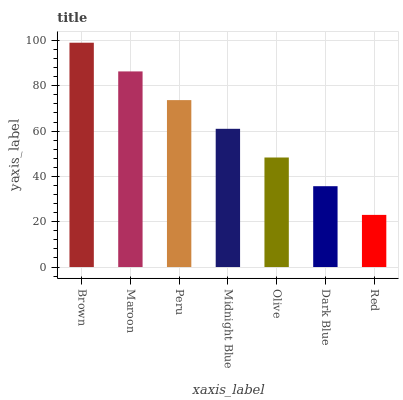Is Red the minimum?
Answer yes or no. Yes. Is Brown the maximum?
Answer yes or no. Yes. Is Maroon the minimum?
Answer yes or no. No. Is Maroon the maximum?
Answer yes or no. No. Is Brown greater than Maroon?
Answer yes or no. Yes. Is Maroon less than Brown?
Answer yes or no. Yes. Is Maroon greater than Brown?
Answer yes or no. No. Is Brown less than Maroon?
Answer yes or no. No. Is Midnight Blue the high median?
Answer yes or no. Yes. Is Midnight Blue the low median?
Answer yes or no. Yes. Is Brown the high median?
Answer yes or no. No. Is Peru the low median?
Answer yes or no. No. 